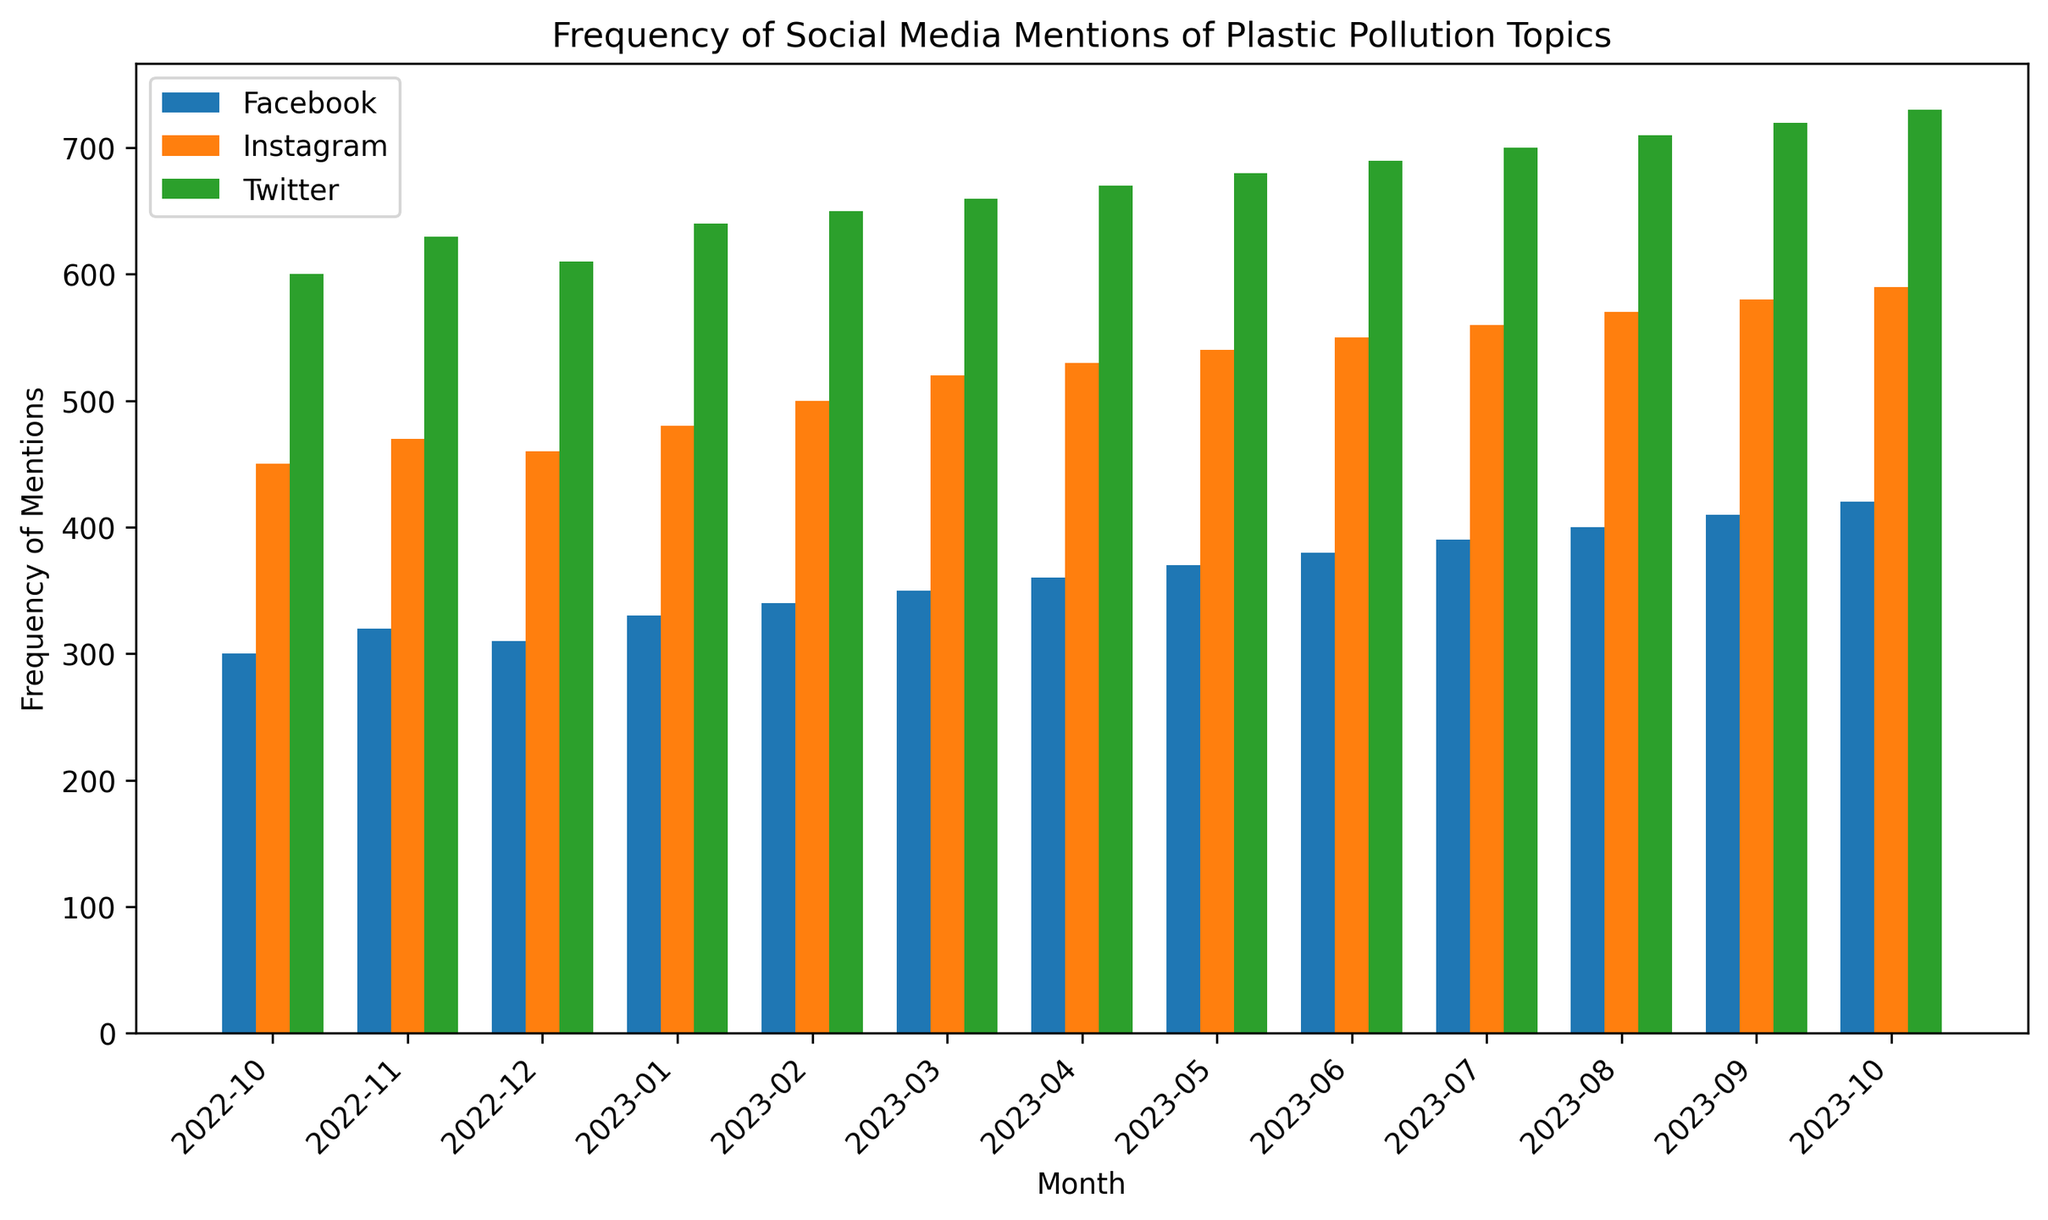What month had the highest frequency of mentions on Twitter? By examining the height of the bars for each month corresponding to Twitter, the tallest bar represents the highest frequency. The highest bar for Twitter occurs in October 2023 with 730 mentions.
Answer: October 2023 In which month did Instagram have the lowest mentions of plastic pollution topics? By looking at the heights of the bars for Instagram, the shortest bar indicates the lowest frequency. The shortest bar for Instagram occurs in October 2022 with 450 mentions.
Answer: October 2022 What is the total number of mentions across all platforms in January 2023? Sum the frequencies for each platform in January 2023: 330 (Facebook) + 480 (Instagram) + 640 (Twitter) = 1450 mentions.
Answer: 1450 Which platform showed a consistent month-over-month increase in mentions? By comparing the height of the bars for each platform month-over-month, Facebook, Instagram, and Twitter all increase consistently each month.
Answer: Facebook, Instagram, and Twitter What is the average frequency of mentions on Facebook for the last three months? Sum the frequencies for Facebook in August, September, and October 2023: 400 + 410 + 420 = 1230, then divide by 3 (months): 1230 / 3 = 410 mentions.
Answer: 410 How does the frequency of mentions in May 2023 for Instagram compare to that for Facebook in the same month? The bar for Instagram in May 2023 is 540, and for Facebook, it is 370. Instagram has a higher frequency of mentions than Facebook by 540 - 370 = 170 mentions.
Answer: Instagram is higher by 170 mentions In which month was the difference between Instagram and Twitter mentions the smallest? By examining the difference for each month between Instagram and Twitter, the smallest difference is in February 2023 with Twitter (650) and Instagram (500) yielding a difference of 150 mentions.
Answer: February 2023 What is the combined frequency of mentions for all three platforms in October 2022? Sum the frequencies for Facebook, Instagram, and Twitter in October 2022: 300 + 450 + 600 = 1350 mentions.
Answer: 1350 